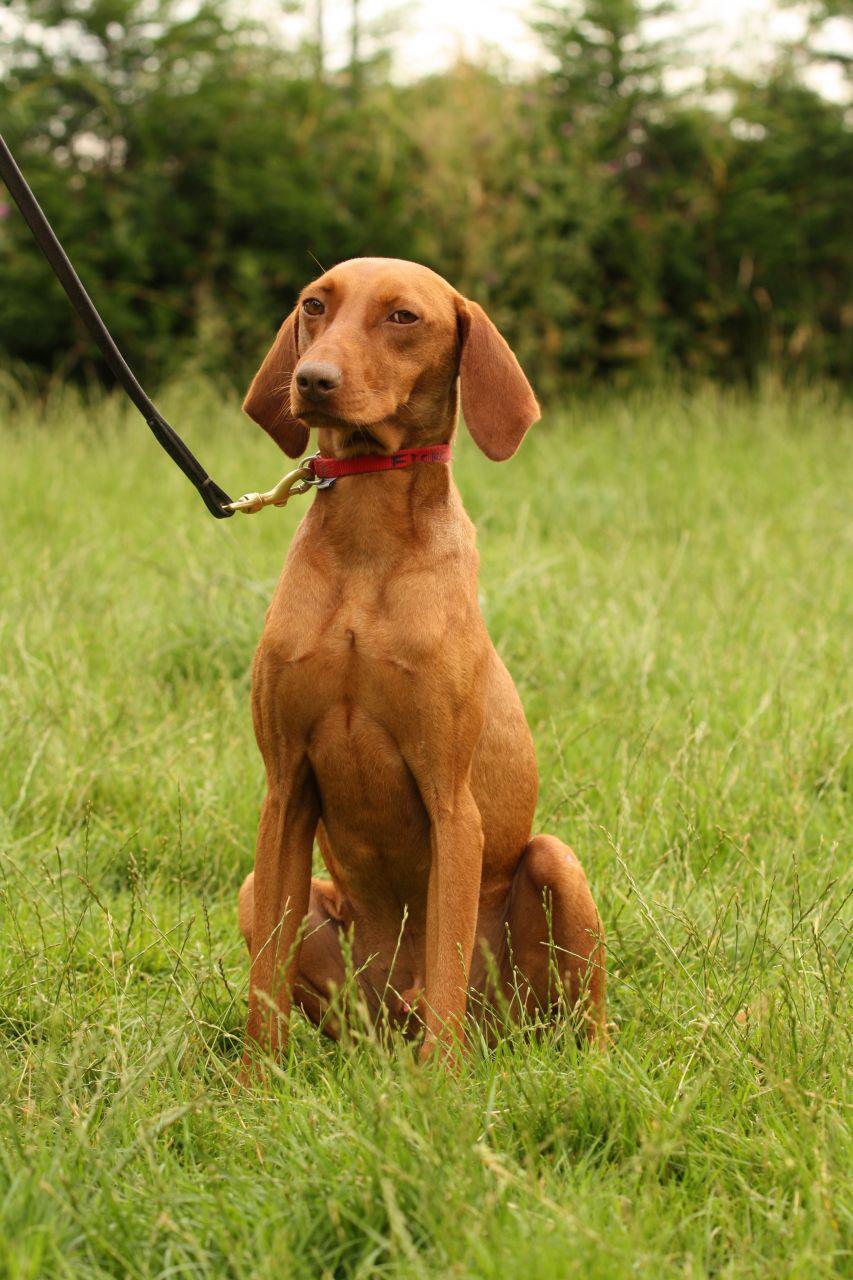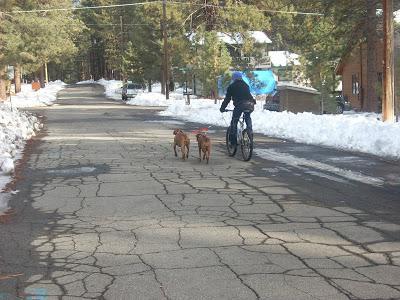The first image is the image on the left, the second image is the image on the right. Considering the images on both sides, is "An image shows two red-orange dogs and a bike rider going down the same path." valid? Answer yes or no. Yes. The first image is the image on the left, the second image is the image on the right. Analyze the images presented: Is the assertion "One person is riding a bicycle near two dogs." valid? Answer yes or no. Yes. 